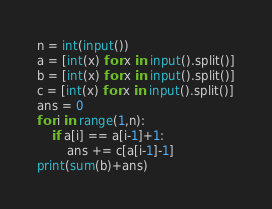<code> <loc_0><loc_0><loc_500><loc_500><_Python_>n = int(input())
a = [int(x) for x in input().split()]
b = [int(x) for x in input().split()]
c = [int(x) for x in input().split()]
ans = 0
for i in range(1,n):
    if a[i] == a[i-1]+1:
        ans += c[a[i-1]-1]
print(sum(b)+ans)</code> 